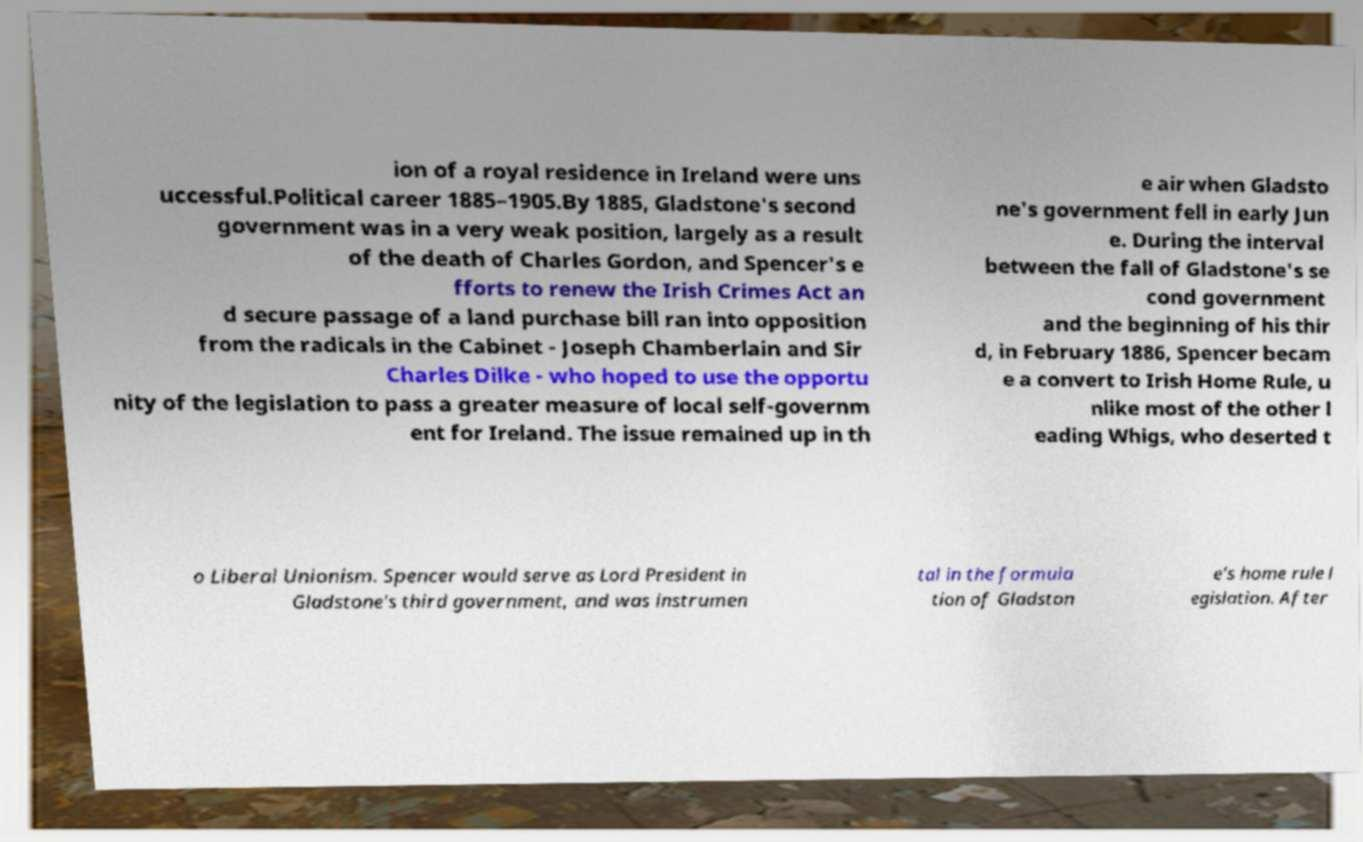What messages or text are displayed in this image? I need them in a readable, typed format. ion of a royal residence in Ireland were uns uccessful.Political career 1885–1905.By 1885, Gladstone's second government was in a very weak position, largely as a result of the death of Charles Gordon, and Spencer's e fforts to renew the Irish Crimes Act an d secure passage of a land purchase bill ran into opposition from the radicals in the Cabinet - Joseph Chamberlain and Sir Charles Dilke - who hoped to use the opportu nity of the legislation to pass a greater measure of local self-governm ent for Ireland. The issue remained up in th e air when Gladsto ne's government fell in early Jun e. During the interval between the fall of Gladstone's se cond government and the beginning of his thir d, in February 1886, Spencer becam e a convert to Irish Home Rule, u nlike most of the other l eading Whigs, who deserted t o Liberal Unionism. Spencer would serve as Lord President in Gladstone's third government, and was instrumen tal in the formula tion of Gladston e's home rule l egislation. After 